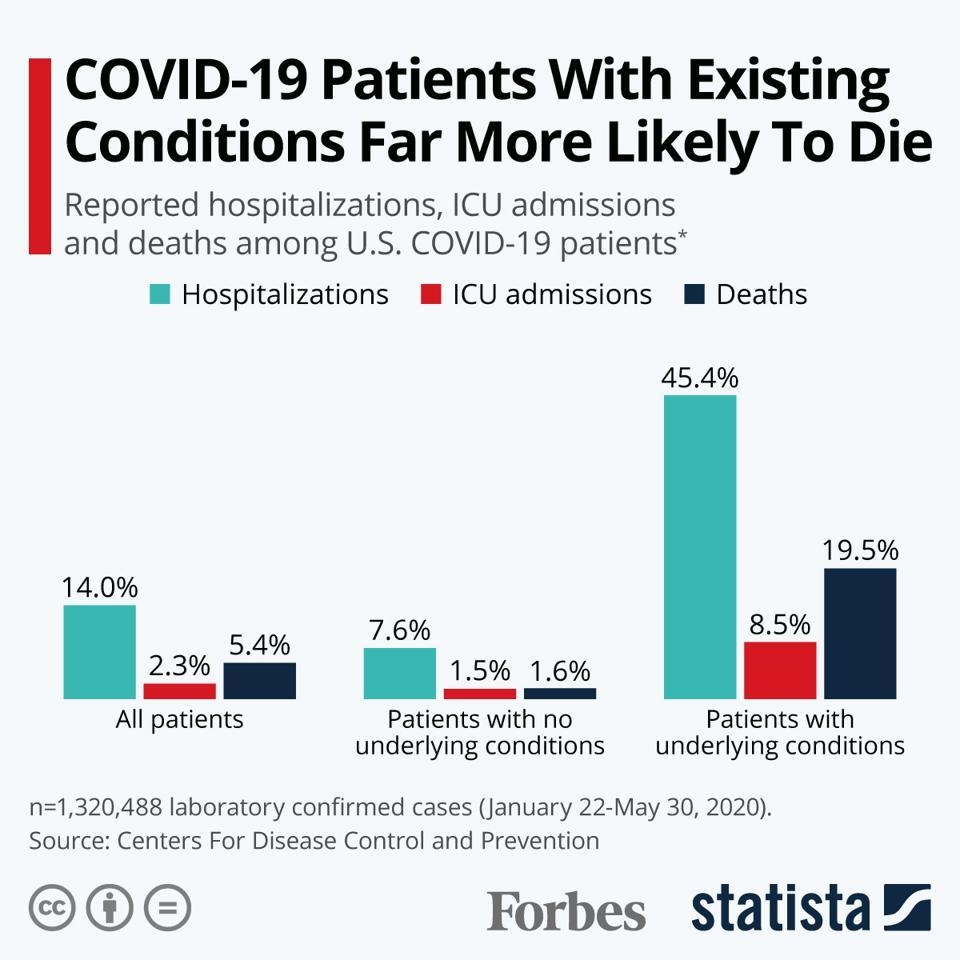Mention a couple of crucial points in this snapshot. Approximately 1.6% of COVID-19 patients with no underlying conditions who were treated in the United States died as a result of the illness. According to data in the United States, among patients with underlying conditions who were diagnosed with Covid-19, 45.4% were hospitalized. A study found that among patients with Covid-19 in the United States who had underlying conditions, 19.5% succumbed to death. Approximately 1.5% of COVID-19 patients in the United States with no underlying medical conditions were admitted to an intensive care unit. In the United States, among patients with Covid-19 who had no underlying medical conditions, 7.6% were hospitalized. 